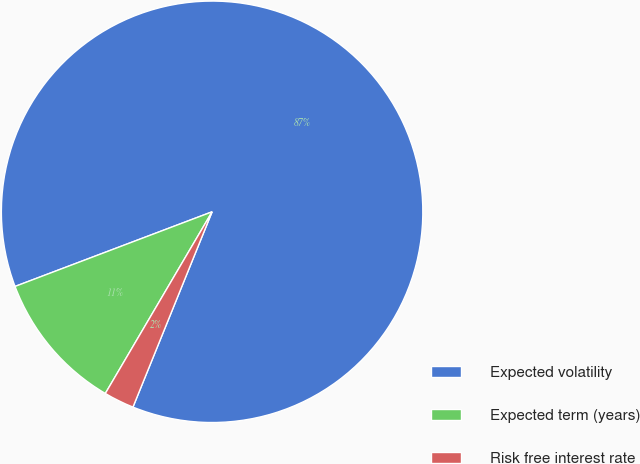<chart> <loc_0><loc_0><loc_500><loc_500><pie_chart><fcel>Expected volatility<fcel>Expected term (years)<fcel>Risk free interest rate<nl><fcel>86.89%<fcel>10.78%<fcel>2.33%<nl></chart> 